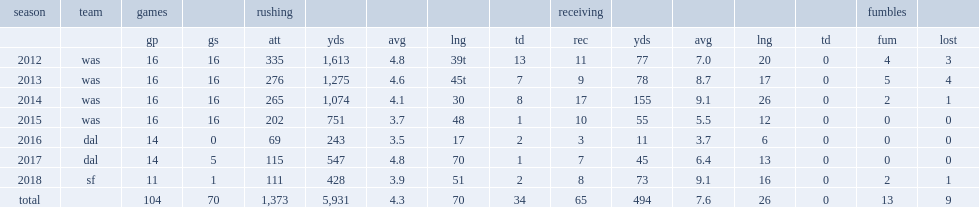How many rushing yards did morris get in 2014? 1074.0. 